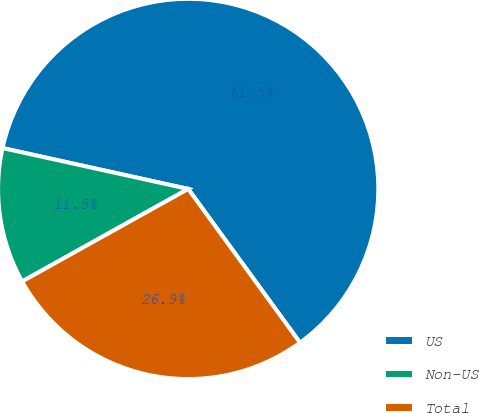<chart> <loc_0><loc_0><loc_500><loc_500><pie_chart><fcel>US<fcel>Non-US<fcel>Total<nl><fcel>61.54%<fcel>11.54%<fcel>26.92%<nl></chart> 